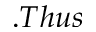Convert formula to latex. <formula><loc_0><loc_0><loc_500><loc_500>. T h u s</formula> 